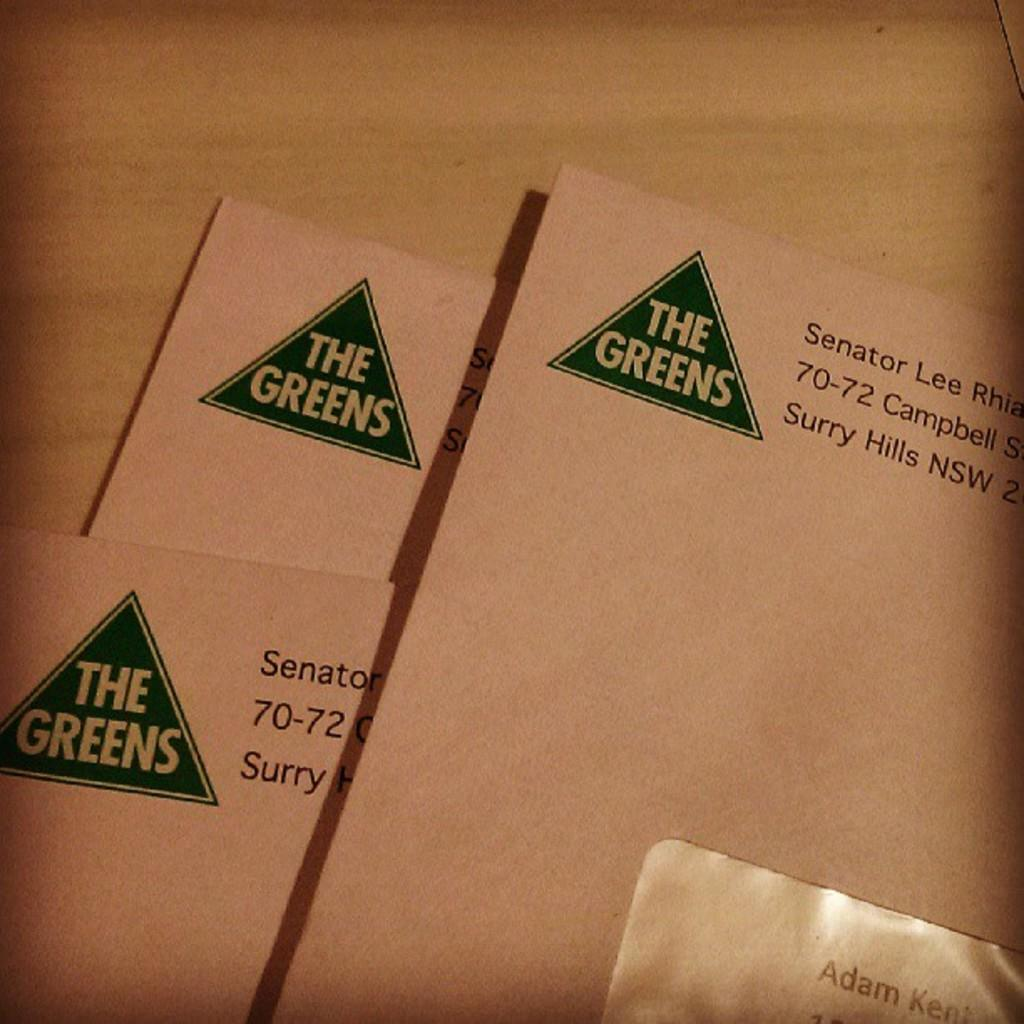<image>
Present a compact description of the photo's key features. Three envelopes with the words the green in the left corner 